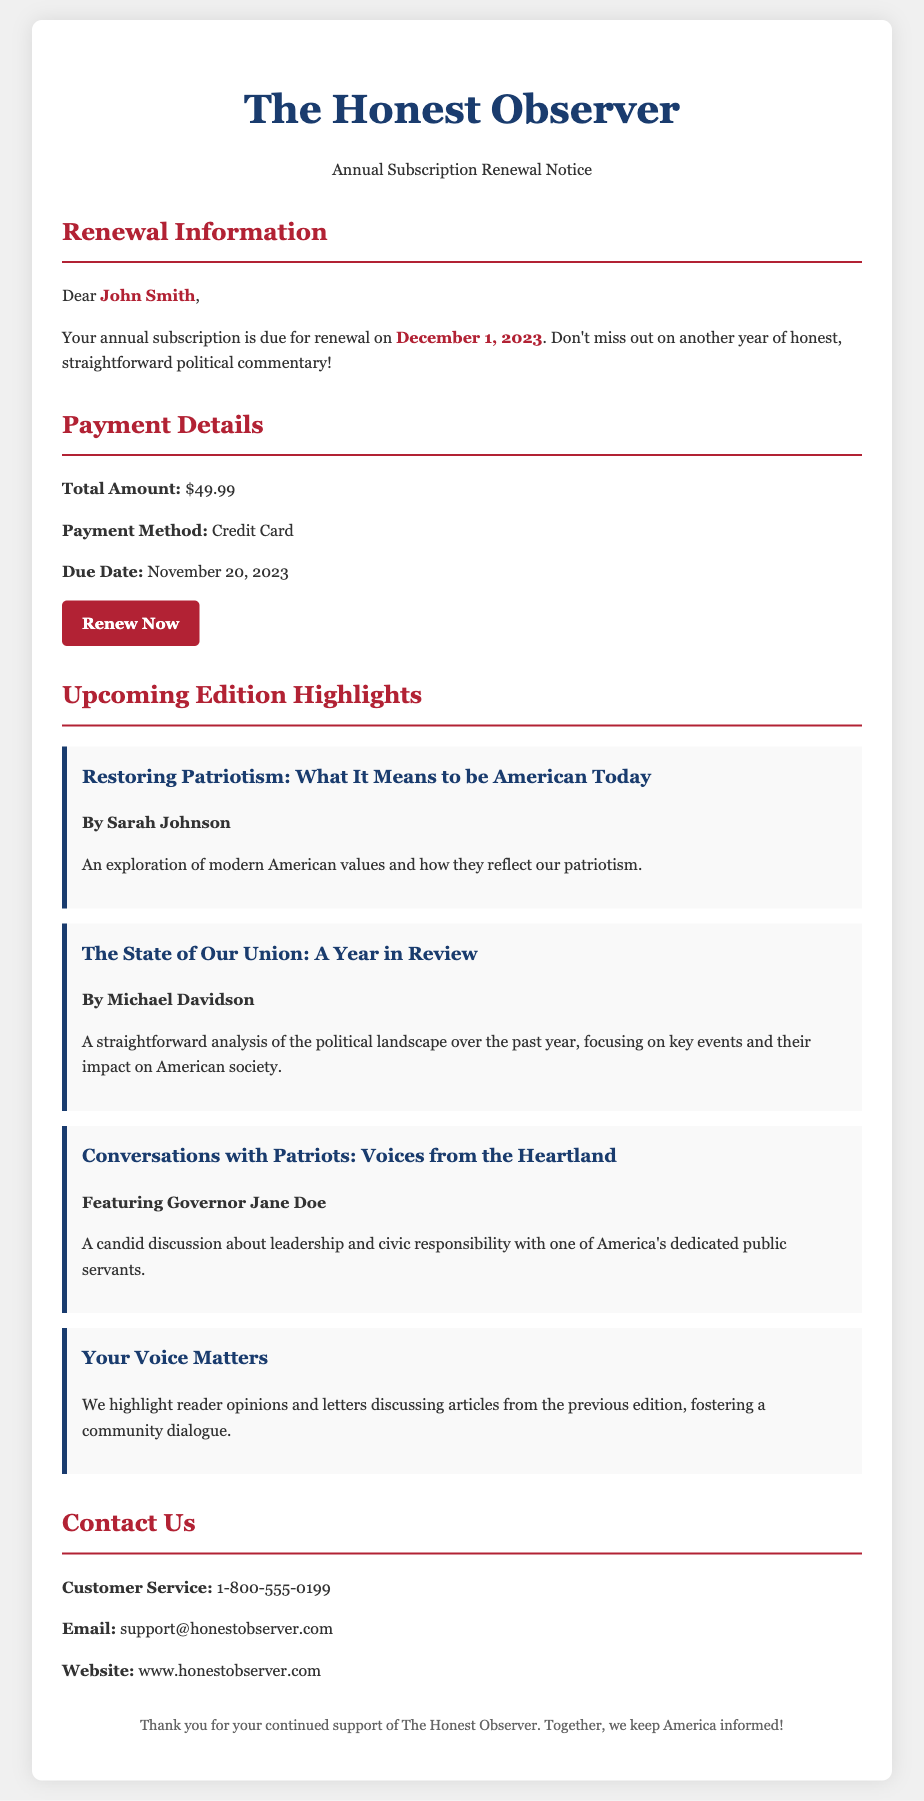What is the name of the magazine? The magazine's name is mentioned in the header of the document as "The Honest Observer."
Answer: The Honest Observer Who is the subscriber addressed in the notice? The subscriber's name is highlighted in the renewal info section, which identifies them as "John Smith."
Answer: John Smith What is the total amount due for renewal? The total amount is specified in the payment details section of the document as "$49.99."
Answer: $49.99 When is the renewal due date? The due date for payment is clearly stated in the payment info section as "November 20, 2023."
Answer: November 20, 2023 What is one of the topics covered in the upcoming edition? The features section lists topics, one of which is "Restoring Patriotism: What It Means to be American Today."
Answer: Restoring Patriotism: What It Means to be American Today Who wrote the article titled "The State of Our Union: A Year in Review"? The author of this article is mentioned in the features section as "Michael Davidson."
Answer: Michael Davidson What is the main focus of the article "Conversations with Patriots: Voices from the Heartland"? The focus of this article is a discussion about leadership and civic responsibility, featuring "Governor Jane Doe."
Answer: Leadership and civic responsibility How can subscribers contact customer service? The customer service contact details are provided, specifically the phone number "1-800-555-0199."
Answer: 1-800-555-0199 What is the purpose of the section "Your Voice Matters"? This section aims to highlight reader opinions and letters discussing articles from the previous edition.
Answer: Highlight reader opinions and letters 